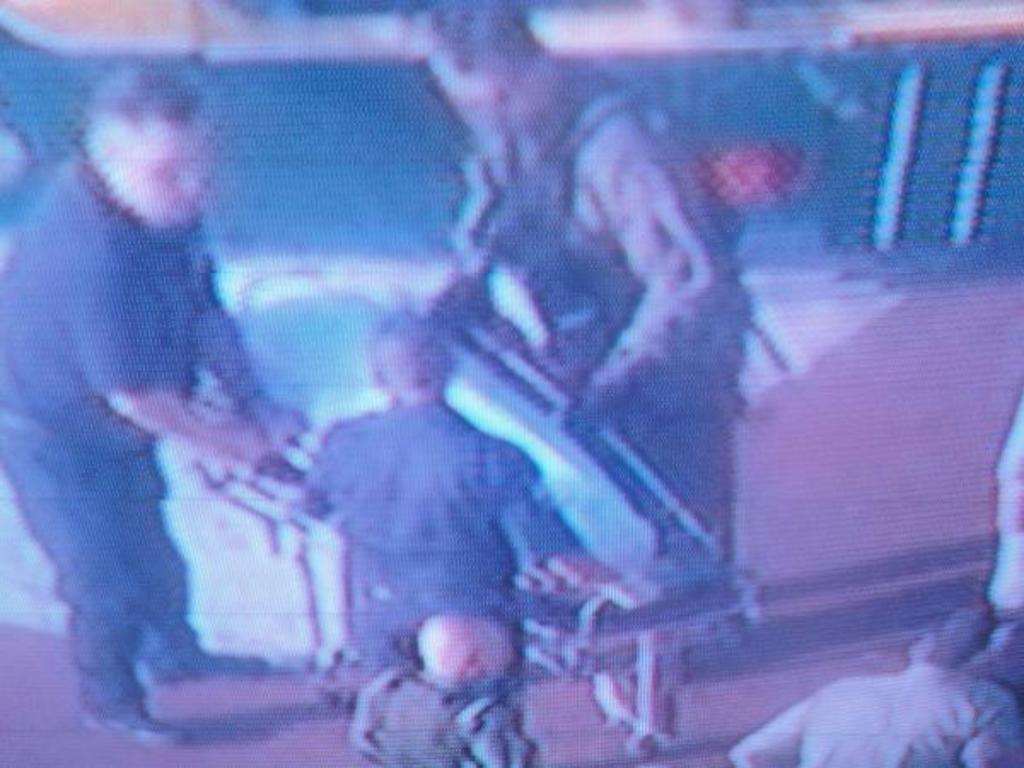Please provide a concise description of this image. In this image there are people standing and it is blurred. 